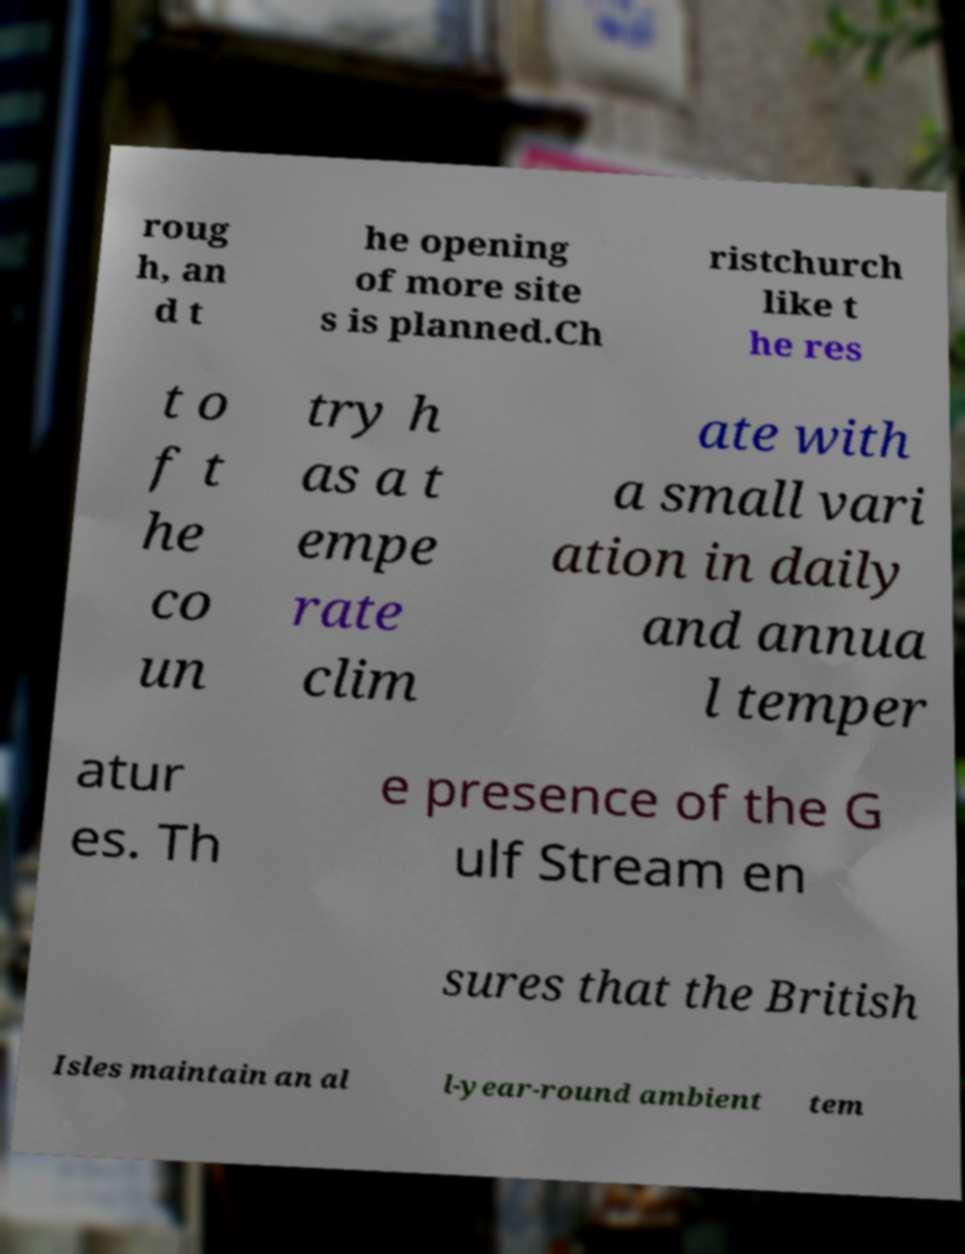Could you extract and type out the text from this image? roug h, an d t he opening of more site s is planned.Ch ristchurch like t he res t o f t he co un try h as a t empe rate clim ate with a small vari ation in daily and annua l temper atur es. Th e presence of the G ulf Stream en sures that the British Isles maintain an al l-year-round ambient tem 